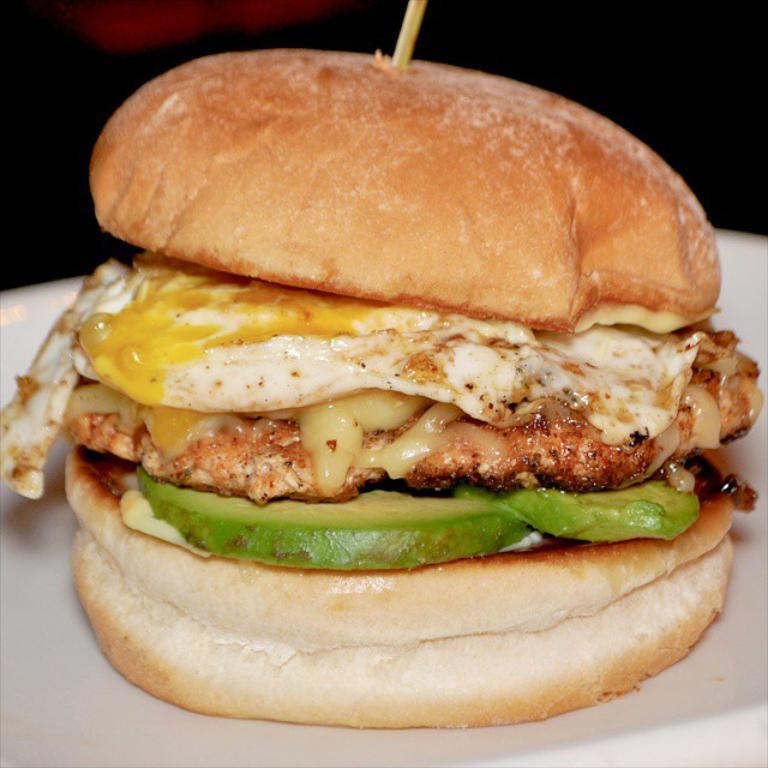What type of food is visible in the image? There is a burger in the image. Is there anything unusual about the presentation of the burger? Yes, the burger has a stick placed on it. Where is the burger located in the image? The burger is placed on a plate. What type of dress is the friend wearing while running in the image? There is no friend, running, or dress present in the image; it only features a burger with a stick on it, placed on a plate. 